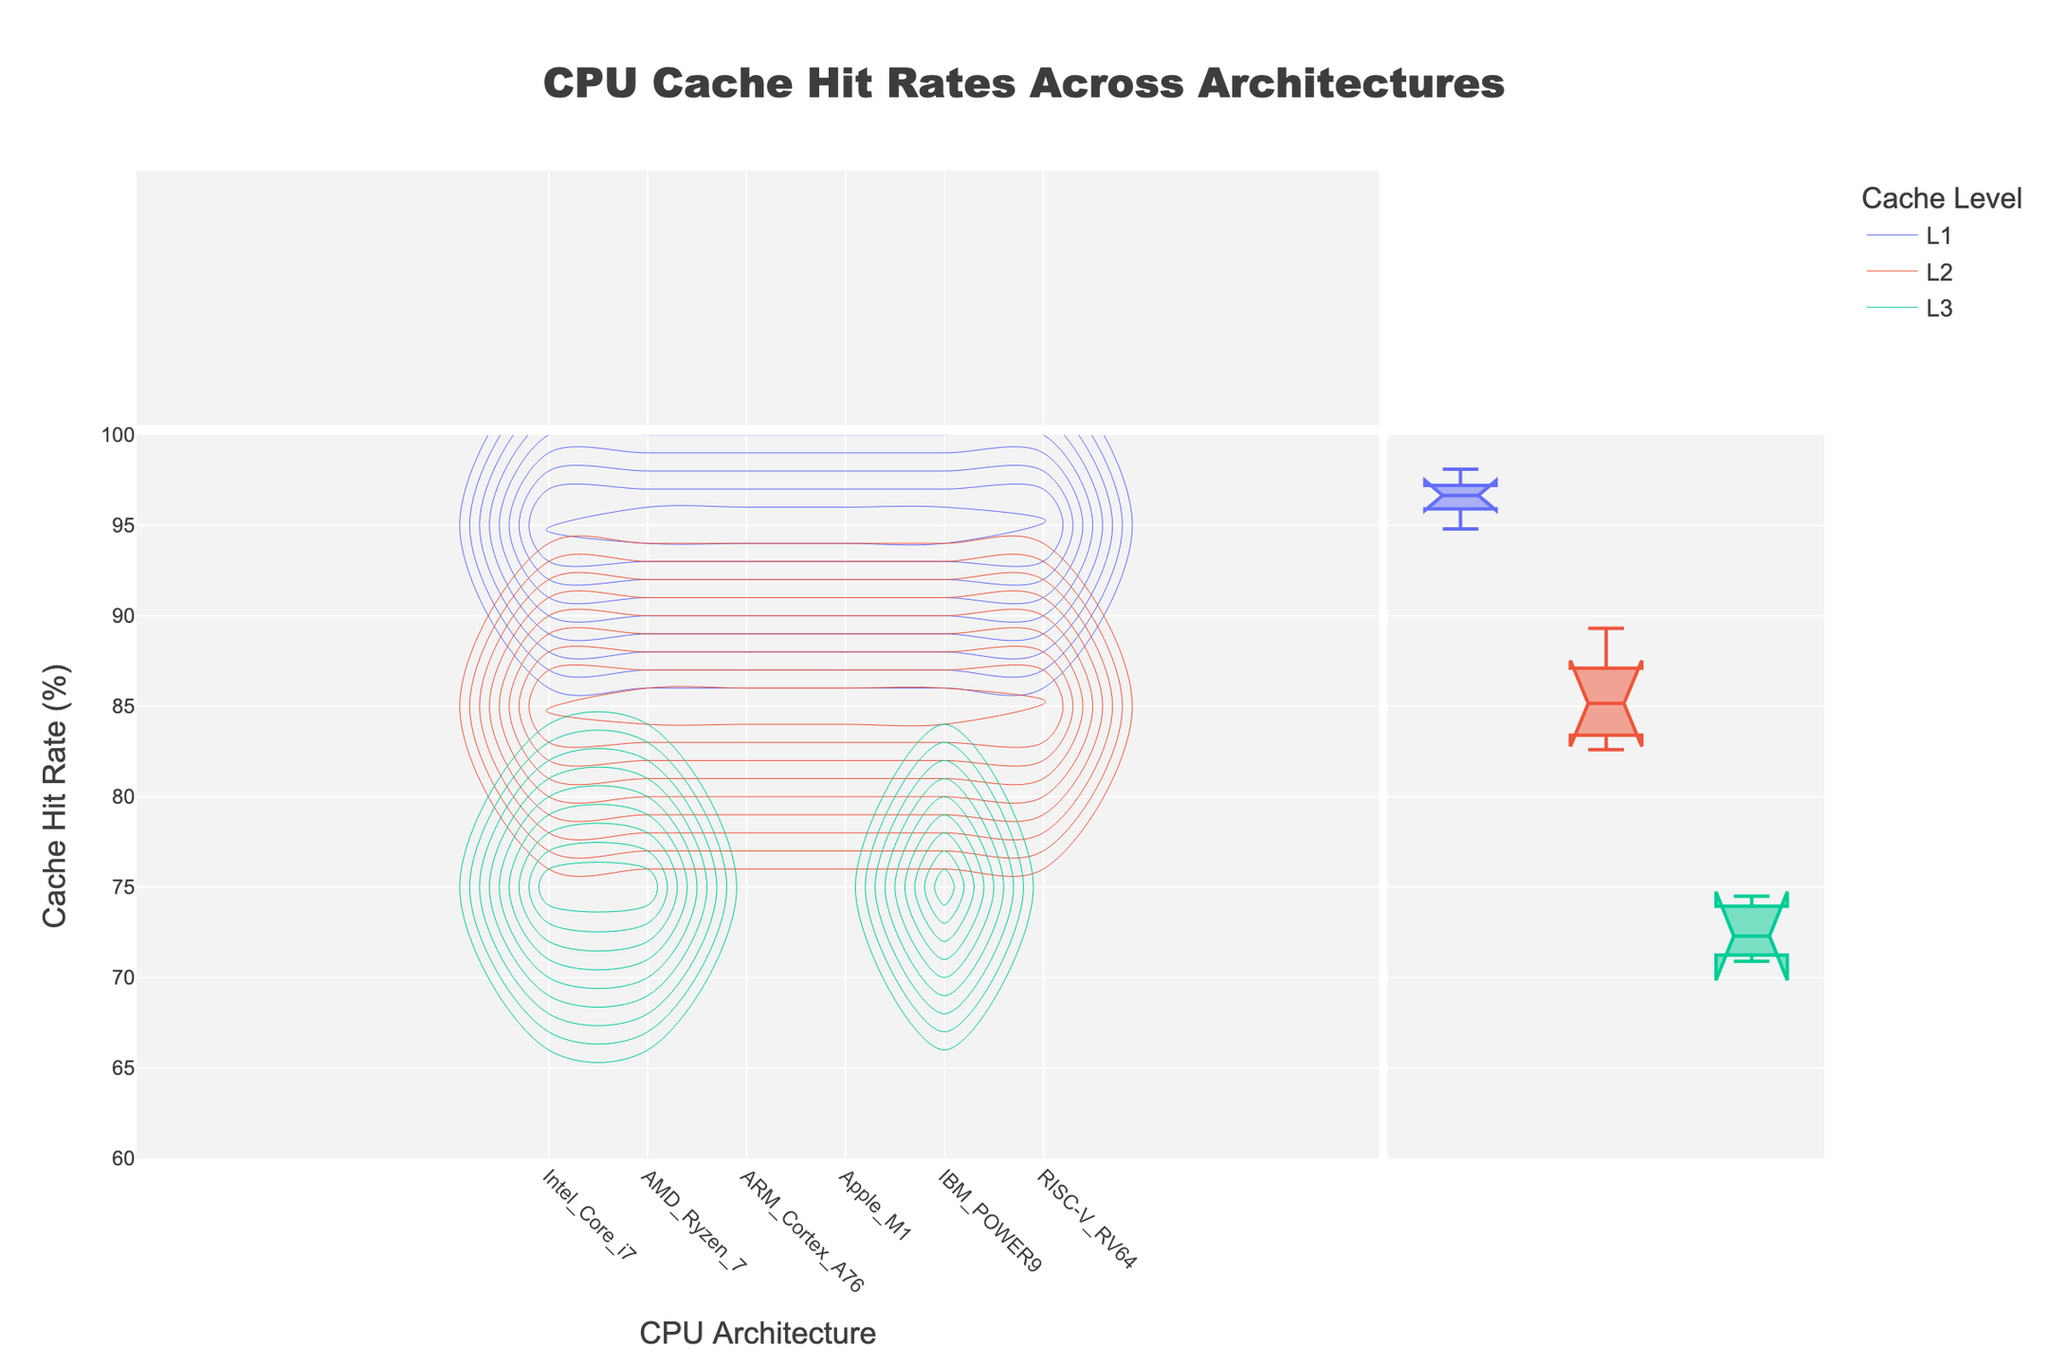What's the title of the figure? The title of the figure is usually displayed at the top and provides a summary of what the figure is about. In this case, it's mentioned in the code that sets the layout title.
Answer: CPU Cache Hit Rates Across Architectures Which CPU architecture has the highest L1 cache hit rate? To find the highest L1 cache hit rate, look at the L1 cache level distinction, then identify the highest point on the hit rate axis among all architectures. According to the data, the highest L1 hit rate is for the Apple M1 at 98.1%.
Answer: Apple M1 What is the L3 cache hit rate for IBM_POWER9 compared to AMD_Ryzen_7? By analyzing the L3 cache level hit rates, we see that the L3 hit rate for IBM_POWER9 is 70.9%, and for AMD_Ryzen_7, it is 74.5%. Comparing these two, we find that AMD_Ryzen_7 has a higher L3 cache hit rate
Answer: AMD_Ryzen_7 Which CPU architecture has the lowest L2 cache hit rate? To find the architecture with the lowest L2 cache hit rate, look for the lowest point on the hit rate axis within the L2 category. According to the data, ARM_Cortex_A76 has the lowest L2 hit rate at 83.4%.
Answer: ARM_Cortex_A76 What is the hit rate difference between L1 and L2 cache levels for Apple M1? To calculate the difference, subtract the L2 hit rate from the L1 hit rate. For Apple M1, the L1 hit rate is 98.1%, and the L2 hit rate is 89.3%. The difference is 98.1 - 89.3 = 8.8%.
Answer: 8.8% Which cache level generally has lower hit rates across all CPU architectures? By observing the contours and distributions of hit rates across cache levels, we see that L3 generally has lower hit rates compared to L1 and L2, according to the data trends.
Answer: L3 How do the L2 cache hit rates of Intel Core i7 and IBM POWER9 compare? To compare the L2 cache hit rates of these CPUs, identify their respective hit rates: Intel Core i7 has an L2 hit rate of 85.6%, and IBM POWER9 has an L2 hit rate of 84.7%. Intel Core i7 has a slightly higher L2 hit rate than IBM POWER9.
Answer: Intel Core i7 What is the average L2 cache hit rate for all CPU architectures? To find the average L2 cache hit rate, sum all the L2 hit rates and divide by the number of architectures: (85.6 + 87.1 + 83.4 + 89.3 + 84.7 + 82.6) / 6 = 85.45%.
Answer: 85.45% What is the range of hit rates for L1 cache across all CPU architectures? The range is calculated as the difference between the highest and lowest hit rates for L1 cache. The highest L1 hit rate is 98.1% (Apple M1), and the lowest is 94.8% (RISC-V RV64). The range is 98.1 - 94.8 = 3.3%.
Answer: 3.3% Which CPU architecture shows the most varied hit rates across different cache levels? To determine variability, look at the range of hit rates within each CPU architecture for different cache levels. The Intel Core i7's hit rates vary from 97.2% (L1) to 72.3% (L3), showing the highest spread.
Answer: Intel Core i7 